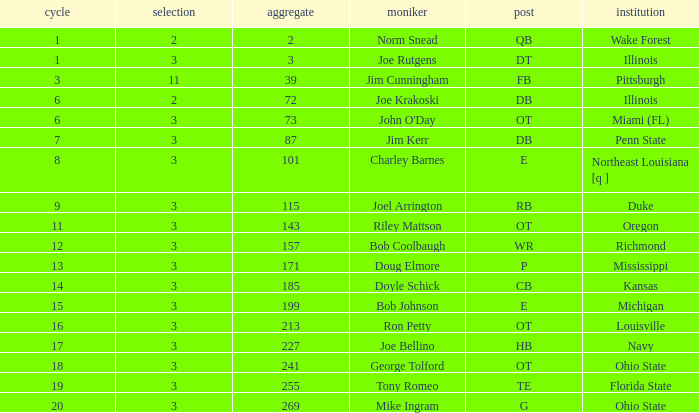How many rounds have john o'day as the name, and a pick less than 3? None. 